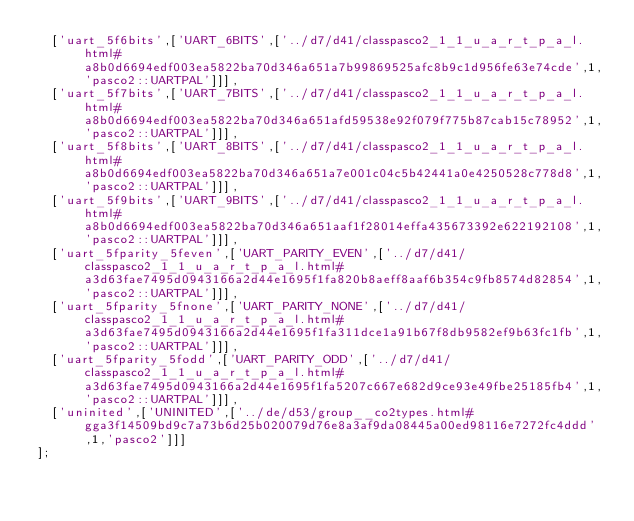Convert code to text. <code><loc_0><loc_0><loc_500><loc_500><_JavaScript_>  ['uart_5f6bits',['UART_6BITS',['../d7/d41/classpasco2_1_1_u_a_r_t_p_a_l.html#a8b0d6694edf003ea5822ba70d346a651a7b99869525afc8b9c1d956fe63e74cde',1,'pasco2::UARTPAL']]],
  ['uart_5f7bits',['UART_7BITS',['../d7/d41/classpasco2_1_1_u_a_r_t_p_a_l.html#a8b0d6694edf003ea5822ba70d346a651afd59538e92f079f775b87cab15c78952',1,'pasco2::UARTPAL']]],
  ['uart_5f8bits',['UART_8BITS',['../d7/d41/classpasco2_1_1_u_a_r_t_p_a_l.html#a8b0d6694edf003ea5822ba70d346a651a7e001c04c5b42441a0e4250528c778d8',1,'pasco2::UARTPAL']]],
  ['uart_5f9bits',['UART_9BITS',['../d7/d41/classpasco2_1_1_u_a_r_t_p_a_l.html#a8b0d6694edf003ea5822ba70d346a651aaf1f28014effa435673392e622192108',1,'pasco2::UARTPAL']]],
  ['uart_5fparity_5feven',['UART_PARITY_EVEN',['../d7/d41/classpasco2_1_1_u_a_r_t_p_a_l.html#a3d63fae7495d0943166a2d44e1695f1fa820b8aeff8aaf6b354c9fb8574d82854',1,'pasco2::UARTPAL']]],
  ['uart_5fparity_5fnone',['UART_PARITY_NONE',['../d7/d41/classpasco2_1_1_u_a_r_t_p_a_l.html#a3d63fae7495d0943166a2d44e1695f1fa311dce1a91b67f8db9582ef9b63fc1fb',1,'pasco2::UARTPAL']]],
  ['uart_5fparity_5fodd',['UART_PARITY_ODD',['../d7/d41/classpasco2_1_1_u_a_r_t_p_a_l.html#a3d63fae7495d0943166a2d44e1695f1fa5207c667e682d9ce93e49fbe25185fb4',1,'pasco2::UARTPAL']]],
  ['uninited',['UNINITED',['../de/d53/group__co2types.html#gga3f14509bd9c7a73b6d25b020079d76e8a3af9da08445a00ed98116e7272fc4ddd',1,'pasco2']]]
];
</code> 